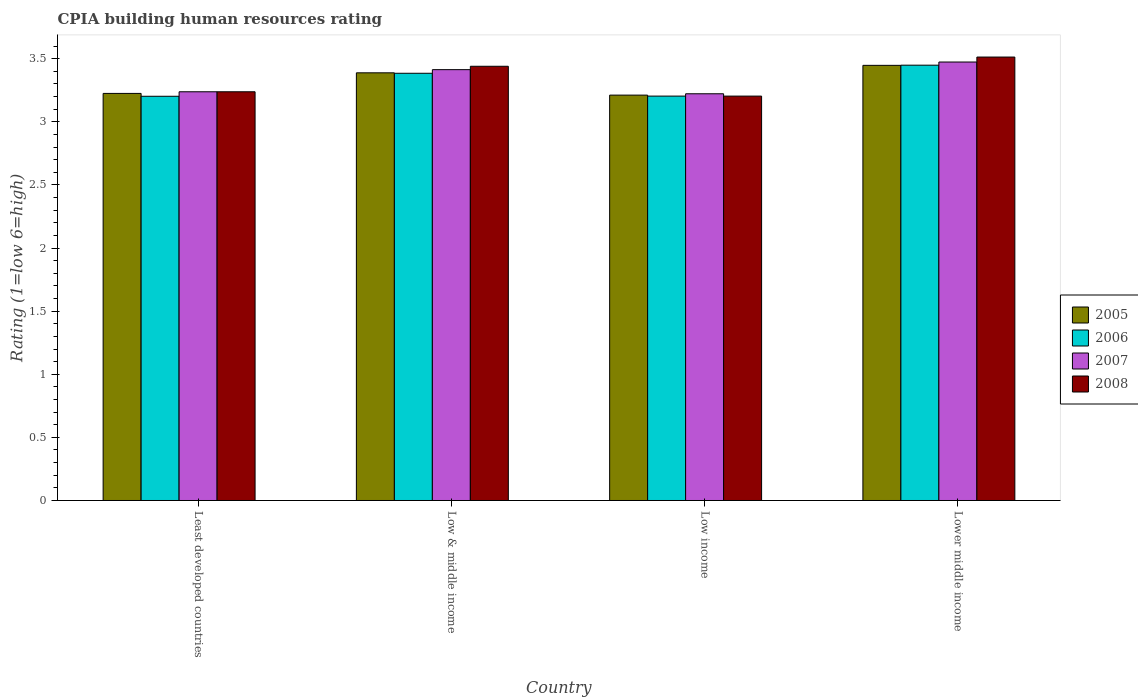In how many cases, is the number of bars for a given country not equal to the number of legend labels?
Your answer should be very brief. 0. What is the CPIA rating in 2005 in Lower middle income?
Your answer should be compact. 3.45. Across all countries, what is the maximum CPIA rating in 2007?
Give a very brief answer. 3.47. Across all countries, what is the minimum CPIA rating in 2007?
Offer a terse response. 3.22. In which country was the CPIA rating in 2007 maximum?
Offer a terse response. Lower middle income. What is the total CPIA rating in 2005 in the graph?
Make the answer very short. 13.27. What is the difference between the CPIA rating in 2007 in Least developed countries and that in Low & middle income?
Ensure brevity in your answer.  -0.18. What is the difference between the CPIA rating in 2005 in Low & middle income and the CPIA rating in 2008 in Lower middle income?
Your response must be concise. -0.12. What is the average CPIA rating in 2008 per country?
Ensure brevity in your answer.  3.35. What is the difference between the CPIA rating of/in 2007 and CPIA rating of/in 2006 in Low income?
Give a very brief answer. 0.02. What is the ratio of the CPIA rating in 2007 in Low income to that in Lower middle income?
Ensure brevity in your answer.  0.93. Is the CPIA rating in 2008 in Least developed countries less than that in Low income?
Offer a terse response. No. What is the difference between the highest and the second highest CPIA rating in 2006?
Ensure brevity in your answer.  -0.06. What is the difference between the highest and the lowest CPIA rating in 2006?
Offer a very short reply. 0.25. Is the sum of the CPIA rating in 2007 in Least developed countries and Low & middle income greater than the maximum CPIA rating in 2008 across all countries?
Your answer should be compact. Yes. Is it the case that in every country, the sum of the CPIA rating in 2008 and CPIA rating in 2006 is greater than the sum of CPIA rating in 2005 and CPIA rating in 2007?
Give a very brief answer. Yes. What does the 3rd bar from the left in Least developed countries represents?
Offer a very short reply. 2007. What does the 3rd bar from the right in Lower middle income represents?
Make the answer very short. 2006. Is it the case that in every country, the sum of the CPIA rating in 2006 and CPIA rating in 2005 is greater than the CPIA rating in 2007?
Keep it short and to the point. Yes. Are the values on the major ticks of Y-axis written in scientific E-notation?
Ensure brevity in your answer.  No. Does the graph contain any zero values?
Ensure brevity in your answer.  No. How many legend labels are there?
Offer a very short reply. 4. What is the title of the graph?
Offer a very short reply. CPIA building human resources rating. Does "1988" appear as one of the legend labels in the graph?
Keep it short and to the point. No. What is the label or title of the Y-axis?
Offer a very short reply. Rating (1=low 6=high). What is the Rating (1=low 6=high) of 2005 in Least developed countries?
Keep it short and to the point. 3.23. What is the Rating (1=low 6=high) in 2006 in Least developed countries?
Your answer should be very brief. 3.2. What is the Rating (1=low 6=high) in 2007 in Least developed countries?
Provide a short and direct response. 3.24. What is the Rating (1=low 6=high) of 2008 in Least developed countries?
Keep it short and to the point. 3.24. What is the Rating (1=low 6=high) of 2005 in Low & middle income?
Give a very brief answer. 3.39. What is the Rating (1=low 6=high) of 2006 in Low & middle income?
Offer a terse response. 3.38. What is the Rating (1=low 6=high) of 2007 in Low & middle income?
Provide a succinct answer. 3.41. What is the Rating (1=low 6=high) of 2008 in Low & middle income?
Your answer should be compact. 3.44. What is the Rating (1=low 6=high) of 2005 in Low income?
Offer a terse response. 3.21. What is the Rating (1=low 6=high) in 2006 in Low income?
Offer a very short reply. 3.2. What is the Rating (1=low 6=high) of 2007 in Low income?
Keep it short and to the point. 3.22. What is the Rating (1=low 6=high) in 2008 in Low income?
Offer a very short reply. 3.2. What is the Rating (1=low 6=high) of 2005 in Lower middle income?
Your answer should be very brief. 3.45. What is the Rating (1=low 6=high) of 2006 in Lower middle income?
Give a very brief answer. 3.45. What is the Rating (1=low 6=high) in 2007 in Lower middle income?
Provide a short and direct response. 3.47. What is the Rating (1=low 6=high) of 2008 in Lower middle income?
Give a very brief answer. 3.51. Across all countries, what is the maximum Rating (1=low 6=high) in 2005?
Give a very brief answer. 3.45. Across all countries, what is the maximum Rating (1=low 6=high) in 2006?
Provide a succinct answer. 3.45. Across all countries, what is the maximum Rating (1=low 6=high) in 2007?
Your response must be concise. 3.47. Across all countries, what is the maximum Rating (1=low 6=high) in 2008?
Give a very brief answer. 3.51. Across all countries, what is the minimum Rating (1=low 6=high) in 2005?
Provide a succinct answer. 3.21. Across all countries, what is the minimum Rating (1=low 6=high) in 2006?
Your answer should be compact. 3.2. Across all countries, what is the minimum Rating (1=low 6=high) in 2007?
Your answer should be very brief. 3.22. Across all countries, what is the minimum Rating (1=low 6=high) of 2008?
Provide a short and direct response. 3.2. What is the total Rating (1=low 6=high) in 2005 in the graph?
Provide a short and direct response. 13.27. What is the total Rating (1=low 6=high) in 2006 in the graph?
Your response must be concise. 13.24. What is the total Rating (1=low 6=high) in 2007 in the graph?
Offer a terse response. 13.35. What is the total Rating (1=low 6=high) of 2008 in the graph?
Your answer should be very brief. 13.39. What is the difference between the Rating (1=low 6=high) of 2005 in Least developed countries and that in Low & middle income?
Keep it short and to the point. -0.16. What is the difference between the Rating (1=low 6=high) in 2006 in Least developed countries and that in Low & middle income?
Provide a short and direct response. -0.18. What is the difference between the Rating (1=low 6=high) of 2007 in Least developed countries and that in Low & middle income?
Provide a succinct answer. -0.18. What is the difference between the Rating (1=low 6=high) of 2008 in Least developed countries and that in Low & middle income?
Make the answer very short. -0.2. What is the difference between the Rating (1=low 6=high) in 2005 in Least developed countries and that in Low income?
Make the answer very short. 0.01. What is the difference between the Rating (1=low 6=high) in 2006 in Least developed countries and that in Low income?
Give a very brief answer. -0. What is the difference between the Rating (1=low 6=high) in 2007 in Least developed countries and that in Low income?
Give a very brief answer. 0.02. What is the difference between the Rating (1=low 6=high) of 2008 in Least developed countries and that in Low income?
Your response must be concise. 0.03. What is the difference between the Rating (1=low 6=high) of 2005 in Least developed countries and that in Lower middle income?
Keep it short and to the point. -0.22. What is the difference between the Rating (1=low 6=high) in 2006 in Least developed countries and that in Lower middle income?
Keep it short and to the point. -0.25. What is the difference between the Rating (1=low 6=high) of 2007 in Least developed countries and that in Lower middle income?
Your answer should be very brief. -0.24. What is the difference between the Rating (1=low 6=high) of 2008 in Least developed countries and that in Lower middle income?
Your response must be concise. -0.28. What is the difference between the Rating (1=low 6=high) of 2005 in Low & middle income and that in Low income?
Your answer should be compact. 0.18. What is the difference between the Rating (1=low 6=high) in 2006 in Low & middle income and that in Low income?
Give a very brief answer. 0.18. What is the difference between the Rating (1=low 6=high) in 2007 in Low & middle income and that in Low income?
Ensure brevity in your answer.  0.19. What is the difference between the Rating (1=low 6=high) of 2008 in Low & middle income and that in Low income?
Give a very brief answer. 0.24. What is the difference between the Rating (1=low 6=high) of 2005 in Low & middle income and that in Lower middle income?
Keep it short and to the point. -0.06. What is the difference between the Rating (1=low 6=high) in 2006 in Low & middle income and that in Lower middle income?
Give a very brief answer. -0.06. What is the difference between the Rating (1=low 6=high) of 2007 in Low & middle income and that in Lower middle income?
Keep it short and to the point. -0.06. What is the difference between the Rating (1=low 6=high) of 2008 in Low & middle income and that in Lower middle income?
Make the answer very short. -0.07. What is the difference between the Rating (1=low 6=high) in 2005 in Low income and that in Lower middle income?
Your response must be concise. -0.24. What is the difference between the Rating (1=low 6=high) in 2006 in Low income and that in Lower middle income?
Keep it short and to the point. -0.24. What is the difference between the Rating (1=low 6=high) in 2007 in Low income and that in Lower middle income?
Provide a short and direct response. -0.25. What is the difference between the Rating (1=low 6=high) of 2008 in Low income and that in Lower middle income?
Provide a succinct answer. -0.31. What is the difference between the Rating (1=low 6=high) of 2005 in Least developed countries and the Rating (1=low 6=high) of 2006 in Low & middle income?
Your response must be concise. -0.16. What is the difference between the Rating (1=low 6=high) in 2005 in Least developed countries and the Rating (1=low 6=high) in 2007 in Low & middle income?
Ensure brevity in your answer.  -0.19. What is the difference between the Rating (1=low 6=high) of 2005 in Least developed countries and the Rating (1=low 6=high) of 2008 in Low & middle income?
Your answer should be compact. -0.21. What is the difference between the Rating (1=low 6=high) of 2006 in Least developed countries and the Rating (1=low 6=high) of 2007 in Low & middle income?
Your response must be concise. -0.21. What is the difference between the Rating (1=low 6=high) in 2006 in Least developed countries and the Rating (1=low 6=high) in 2008 in Low & middle income?
Make the answer very short. -0.24. What is the difference between the Rating (1=low 6=high) in 2007 in Least developed countries and the Rating (1=low 6=high) in 2008 in Low & middle income?
Offer a very short reply. -0.2. What is the difference between the Rating (1=low 6=high) in 2005 in Least developed countries and the Rating (1=low 6=high) in 2006 in Low income?
Your response must be concise. 0.02. What is the difference between the Rating (1=low 6=high) in 2005 in Least developed countries and the Rating (1=low 6=high) in 2007 in Low income?
Give a very brief answer. 0. What is the difference between the Rating (1=low 6=high) in 2005 in Least developed countries and the Rating (1=low 6=high) in 2008 in Low income?
Make the answer very short. 0.02. What is the difference between the Rating (1=low 6=high) in 2006 in Least developed countries and the Rating (1=low 6=high) in 2007 in Low income?
Give a very brief answer. -0.02. What is the difference between the Rating (1=low 6=high) of 2006 in Least developed countries and the Rating (1=low 6=high) of 2008 in Low income?
Your answer should be compact. -0. What is the difference between the Rating (1=low 6=high) of 2007 in Least developed countries and the Rating (1=low 6=high) of 2008 in Low income?
Your answer should be compact. 0.03. What is the difference between the Rating (1=low 6=high) of 2005 in Least developed countries and the Rating (1=low 6=high) of 2006 in Lower middle income?
Offer a terse response. -0.22. What is the difference between the Rating (1=low 6=high) of 2005 in Least developed countries and the Rating (1=low 6=high) of 2007 in Lower middle income?
Ensure brevity in your answer.  -0.25. What is the difference between the Rating (1=low 6=high) of 2005 in Least developed countries and the Rating (1=low 6=high) of 2008 in Lower middle income?
Offer a very short reply. -0.29. What is the difference between the Rating (1=low 6=high) of 2006 in Least developed countries and the Rating (1=low 6=high) of 2007 in Lower middle income?
Provide a succinct answer. -0.27. What is the difference between the Rating (1=low 6=high) of 2006 in Least developed countries and the Rating (1=low 6=high) of 2008 in Lower middle income?
Make the answer very short. -0.31. What is the difference between the Rating (1=low 6=high) in 2007 in Least developed countries and the Rating (1=low 6=high) in 2008 in Lower middle income?
Provide a short and direct response. -0.28. What is the difference between the Rating (1=low 6=high) of 2005 in Low & middle income and the Rating (1=low 6=high) of 2006 in Low income?
Offer a terse response. 0.18. What is the difference between the Rating (1=low 6=high) of 2005 in Low & middle income and the Rating (1=low 6=high) of 2007 in Low income?
Keep it short and to the point. 0.17. What is the difference between the Rating (1=low 6=high) in 2005 in Low & middle income and the Rating (1=low 6=high) in 2008 in Low income?
Ensure brevity in your answer.  0.18. What is the difference between the Rating (1=low 6=high) of 2006 in Low & middle income and the Rating (1=low 6=high) of 2007 in Low income?
Make the answer very short. 0.16. What is the difference between the Rating (1=low 6=high) of 2006 in Low & middle income and the Rating (1=low 6=high) of 2008 in Low income?
Your answer should be compact. 0.18. What is the difference between the Rating (1=low 6=high) of 2007 in Low & middle income and the Rating (1=low 6=high) of 2008 in Low income?
Offer a terse response. 0.21. What is the difference between the Rating (1=low 6=high) in 2005 in Low & middle income and the Rating (1=low 6=high) in 2006 in Lower middle income?
Give a very brief answer. -0.06. What is the difference between the Rating (1=low 6=high) in 2005 in Low & middle income and the Rating (1=low 6=high) in 2007 in Lower middle income?
Give a very brief answer. -0.09. What is the difference between the Rating (1=low 6=high) in 2005 in Low & middle income and the Rating (1=low 6=high) in 2008 in Lower middle income?
Ensure brevity in your answer.  -0.12. What is the difference between the Rating (1=low 6=high) in 2006 in Low & middle income and the Rating (1=low 6=high) in 2007 in Lower middle income?
Your answer should be very brief. -0.09. What is the difference between the Rating (1=low 6=high) in 2006 in Low & middle income and the Rating (1=low 6=high) in 2008 in Lower middle income?
Provide a succinct answer. -0.13. What is the difference between the Rating (1=low 6=high) in 2007 in Low & middle income and the Rating (1=low 6=high) in 2008 in Lower middle income?
Offer a very short reply. -0.1. What is the difference between the Rating (1=low 6=high) of 2005 in Low income and the Rating (1=low 6=high) of 2006 in Lower middle income?
Keep it short and to the point. -0.24. What is the difference between the Rating (1=low 6=high) in 2005 in Low income and the Rating (1=low 6=high) in 2007 in Lower middle income?
Offer a very short reply. -0.26. What is the difference between the Rating (1=low 6=high) in 2005 in Low income and the Rating (1=low 6=high) in 2008 in Lower middle income?
Offer a very short reply. -0.3. What is the difference between the Rating (1=low 6=high) of 2006 in Low income and the Rating (1=low 6=high) of 2007 in Lower middle income?
Your answer should be very brief. -0.27. What is the difference between the Rating (1=low 6=high) of 2006 in Low income and the Rating (1=low 6=high) of 2008 in Lower middle income?
Offer a terse response. -0.31. What is the difference between the Rating (1=low 6=high) of 2007 in Low income and the Rating (1=low 6=high) of 2008 in Lower middle income?
Give a very brief answer. -0.29. What is the average Rating (1=low 6=high) of 2005 per country?
Provide a succinct answer. 3.32. What is the average Rating (1=low 6=high) of 2006 per country?
Offer a terse response. 3.31. What is the average Rating (1=low 6=high) of 2007 per country?
Offer a very short reply. 3.34. What is the average Rating (1=low 6=high) in 2008 per country?
Give a very brief answer. 3.35. What is the difference between the Rating (1=low 6=high) in 2005 and Rating (1=low 6=high) in 2006 in Least developed countries?
Your response must be concise. 0.02. What is the difference between the Rating (1=low 6=high) in 2005 and Rating (1=low 6=high) in 2007 in Least developed countries?
Make the answer very short. -0.01. What is the difference between the Rating (1=low 6=high) of 2005 and Rating (1=low 6=high) of 2008 in Least developed countries?
Offer a terse response. -0.01. What is the difference between the Rating (1=low 6=high) in 2006 and Rating (1=low 6=high) in 2007 in Least developed countries?
Offer a very short reply. -0.04. What is the difference between the Rating (1=low 6=high) in 2006 and Rating (1=low 6=high) in 2008 in Least developed countries?
Give a very brief answer. -0.04. What is the difference between the Rating (1=low 6=high) of 2007 and Rating (1=low 6=high) of 2008 in Least developed countries?
Give a very brief answer. 0. What is the difference between the Rating (1=low 6=high) in 2005 and Rating (1=low 6=high) in 2006 in Low & middle income?
Ensure brevity in your answer.  0. What is the difference between the Rating (1=low 6=high) of 2005 and Rating (1=low 6=high) of 2007 in Low & middle income?
Your response must be concise. -0.03. What is the difference between the Rating (1=low 6=high) of 2005 and Rating (1=low 6=high) of 2008 in Low & middle income?
Provide a succinct answer. -0.05. What is the difference between the Rating (1=low 6=high) of 2006 and Rating (1=low 6=high) of 2007 in Low & middle income?
Make the answer very short. -0.03. What is the difference between the Rating (1=low 6=high) of 2006 and Rating (1=low 6=high) of 2008 in Low & middle income?
Ensure brevity in your answer.  -0.06. What is the difference between the Rating (1=low 6=high) in 2007 and Rating (1=low 6=high) in 2008 in Low & middle income?
Your answer should be compact. -0.03. What is the difference between the Rating (1=low 6=high) of 2005 and Rating (1=low 6=high) of 2006 in Low income?
Your response must be concise. 0.01. What is the difference between the Rating (1=low 6=high) in 2005 and Rating (1=low 6=high) in 2007 in Low income?
Your answer should be compact. -0.01. What is the difference between the Rating (1=low 6=high) of 2005 and Rating (1=low 6=high) of 2008 in Low income?
Offer a very short reply. 0.01. What is the difference between the Rating (1=low 6=high) of 2006 and Rating (1=low 6=high) of 2007 in Low income?
Offer a very short reply. -0.02. What is the difference between the Rating (1=low 6=high) in 2006 and Rating (1=low 6=high) in 2008 in Low income?
Provide a succinct answer. 0. What is the difference between the Rating (1=low 6=high) of 2007 and Rating (1=low 6=high) of 2008 in Low income?
Keep it short and to the point. 0.02. What is the difference between the Rating (1=low 6=high) of 2005 and Rating (1=low 6=high) of 2006 in Lower middle income?
Your response must be concise. -0. What is the difference between the Rating (1=low 6=high) of 2005 and Rating (1=low 6=high) of 2007 in Lower middle income?
Make the answer very short. -0.03. What is the difference between the Rating (1=low 6=high) in 2005 and Rating (1=low 6=high) in 2008 in Lower middle income?
Keep it short and to the point. -0.07. What is the difference between the Rating (1=low 6=high) of 2006 and Rating (1=low 6=high) of 2007 in Lower middle income?
Make the answer very short. -0.03. What is the difference between the Rating (1=low 6=high) in 2006 and Rating (1=low 6=high) in 2008 in Lower middle income?
Offer a very short reply. -0.06. What is the difference between the Rating (1=low 6=high) of 2007 and Rating (1=low 6=high) of 2008 in Lower middle income?
Offer a very short reply. -0.04. What is the ratio of the Rating (1=low 6=high) of 2005 in Least developed countries to that in Low & middle income?
Your answer should be very brief. 0.95. What is the ratio of the Rating (1=low 6=high) of 2006 in Least developed countries to that in Low & middle income?
Your answer should be very brief. 0.95. What is the ratio of the Rating (1=low 6=high) of 2007 in Least developed countries to that in Low & middle income?
Your answer should be very brief. 0.95. What is the ratio of the Rating (1=low 6=high) in 2008 in Least developed countries to that in Low & middle income?
Give a very brief answer. 0.94. What is the ratio of the Rating (1=low 6=high) of 2005 in Least developed countries to that in Low income?
Your response must be concise. 1. What is the ratio of the Rating (1=low 6=high) in 2007 in Least developed countries to that in Low income?
Keep it short and to the point. 1. What is the ratio of the Rating (1=low 6=high) in 2008 in Least developed countries to that in Low income?
Your answer should be compact. 1.01. What is the ratio of the Rating (1=low 6=high) of 2005 in Least developed countries to that in Lower middle income?
Provide a succinct answer. 0.94. What is the ratio of the Rating (1=low 6=high) of 2007 in Least developed countries to that in Lower middle income?
Your answer should be very brief. 0.93. What is the ratio of the Rating (1=low 6=high) in 2008 in Least developed countries to that in Lower middle income?
Provide a short and direct response. 0.92. What is the ratio of the Rating (1=low 6=high) in 2005 in Low & middle income to that in Low income?
Offer a terse response. 1.05. What is the ratio of the Rating (1=low 6=high) of 2006 in Low & middle income to that in Low income?
Provide a succinct answer. 1.06. What is the ratio of the Rating (1=low 6=high) in 2007 in Low & middle income to that in Low income?
Provide a succinct answer. 1.06. What is the ratio of the Rating (1=low 6=high) of 2008 in Low & middle income to that in Low income?
Make the answer very short. 1.07. What is the ratio of the Rating (1=low 6=high) in 2005 in Low & middle income to that in Lower middle income?
Give a very brief answer. 0.98. What is the ratio of the Rating (1=low 6=high) of 2006 in Low & middle income to that in Lower middle income?
Keep it short and to the point. 0.98. What is the ratio of the Rating (1=low 6=high) of 2007 in Low & middle income to that in Lower middle income?
Give a very brief answer. 0.98. What is the ratio of the Rating (1=low 6=high) of 2008 in Low & middle income to that in Lower middle income?
Make the answer very short. 0.98. What is the ratio of the Rating (1=low 6=high) of 2005 in Low income to that in Lower middle income?
Give a very brief answer. 0.93. What is the ratio of the Rating (1=low 6=high) of 2006 in Low income to that in Lower middle income?
Your answer should be very brief. 0.93. What is the ratio of the Rating (1=low 6=high) of 2007 in Low income to that in Lower middle income?
Make the answer very short. 0.93. What is the ratio of the Rating (1=low 6=high) in 2008 in Low income to that in Lower middle income?
Ensure brevity in your answer.  0.91. What is the difference between the highest and the second highest Rating (1=low 6=high) in 2005?
Provide a succinct answer. 0.06. What is the difference between the highest and the second highest Rating (1=low 6=high) of 2006?
Ensure brevity in your answer.  0.06. What is the difference between the highest and the second highest Rating (1=low 6=high) in 2007?
Your response must be concise. 0.06. What is the difference between the highest and the second highest Rating (1=low 6=high) in 2008?
Your response must be concise. 0.07. What is the difference between the highest and the lowest Rating (1=low 6=high) in 2005?
Offer a very short reply. 0.24. What is the difference between the highest and the lowest Rating (1=low 6=high) in 2006?
Ensure brevity in your answer.  0.25. What is the difference between the highest and the lowest Rating (1=low 6=high) of 2007?
Make the answer very short. 0.25. What is the difference between the highest and the lowest Rating (1=low 6=high) of 2008?
Your answer should be compact. 0.31. 